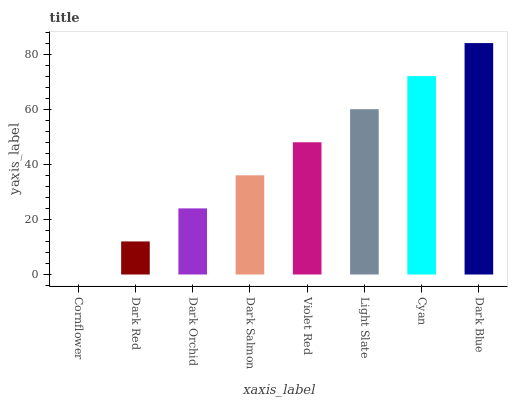Is Cornflower the minimum?
Answer yes or no. Yes. Is Dark Blue the maximum?
Answer yes or no. Yes. Is Dark Red the minimum?
Answer yes or no. No. Is Dark Red the maximum?
Answer yes or no. No. Is Dark Red greater than Cornflower?
Answer yes or no. Yes. Is Cornflower less than Dark Red?
Answer yes or no. Yes. Is Cornflower greater than Dark Red?
Answer yes or no. No. Is Dark Red less than Cornflower?
Answer yes or no. No. Is Violet Red the high median?
Answer yes or no. Yes. Is Dark Salmon the low median?
Answer yes or no. Yes. Is Dark Blue the high median?
Answer yes or no. No. Is Dark Red the low median?
Answer yes or no. No. 